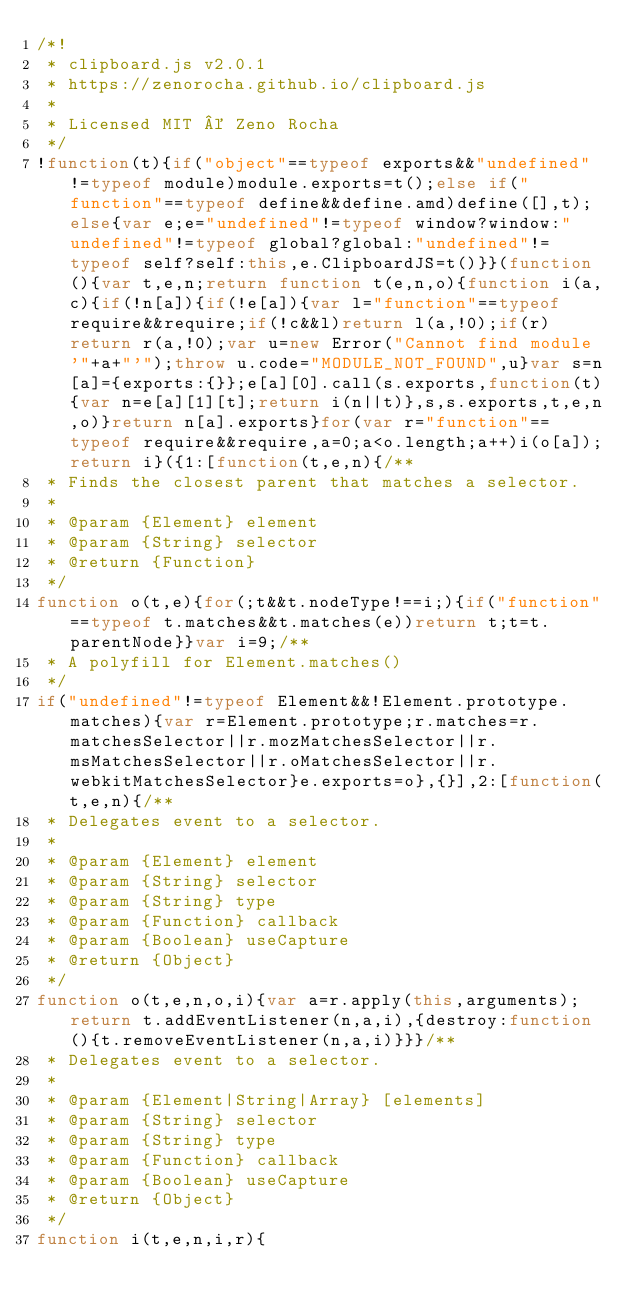Convert code to text. <code><loc_0><loc_0><loc_500><loc_500><_JavaScript_>/*!
 * clipboard.js v2.0.1
 * https://zenorocha.github.io/clipboard.js
 *
 * Licensed MIT © Zeno Rocha
 */
!function(t){if("object"==typeof exports&&"undefined"!=typeof module)module.exports=t();else if("function"==typeof define&&define.amd)define([],t);else{var e;e="undefined"!=typeof window?window:"undefined"!=typeof global?global:"undefined"!=typeof self?self:this,e.ClipboardJS=t()}}(function(){var t,e,n;return function t(e,n,o){function i(a,c){if(!n[a]){if(!e[a]){var l="function"==typeof require&&require;if(!c&&l)return l(a,!0);if(r)return r(a,!0);var u=new Error("Cannot find module '"+a+"'");throw u.code="MODULE_NOT_FOUND",u}var s=n[a]={exports:{}};e[a][0].call(s.exports,function(t){var n=e[a][1][t];return i(n||t)},s,s.exports,t,e,n,o)}return n[a].exports}for(var r="function"==typeof require&&require,a=0;a<o.length;a++)i(o[a]);return i}({1:[function(t,e,n){/**
 * Finds the closest parent that matches a selector.
 *
 * @param {Element} element
 * @param {String} selector
 * @return {Function}
 */
function o(t,e){for(;t&&t.nodeType!==i;){if("function"==typeof t.matches&&t.matches(e))return t;t=t.parentNode}}var i=9;/**
 * A polyfill for Element.matches()
 */
if("undefined"!=typeof Element&&!Element.prototype.matches){var r=Element.prototype;r.matches=r.matchesSelector||r.mozMatchesSelector||r.msMatchesSelector||r.oMatchesSelector||r.webkitMatchesSelector}e.exports=o},{}],2:[function(t,e,n){/**
 * Delegates event to a selector.
 *
 * @param {Element} element
 * @param {String} selector
 * @param {String} type
 * @param {Function} callback
 * @param {Boolean} useCapture
 * @return {Object}
 */
function o(t,e,n,o,i){var a=r.apply(this,arguments);return t.addEventListener(n,a,i),{destroy:function(){t.removeEventListener(n,a,i)}}}/**
 * Delegates event to a selector.
 *
 * @param {Element|String|Array} [elements]
 * @param {String} selector
 * @param {String} type
 * @param {Function} callback
 * @param {Boolean} useCapture
 * @return {Object}
 */
function i(t,e,n,i,r){</code> 